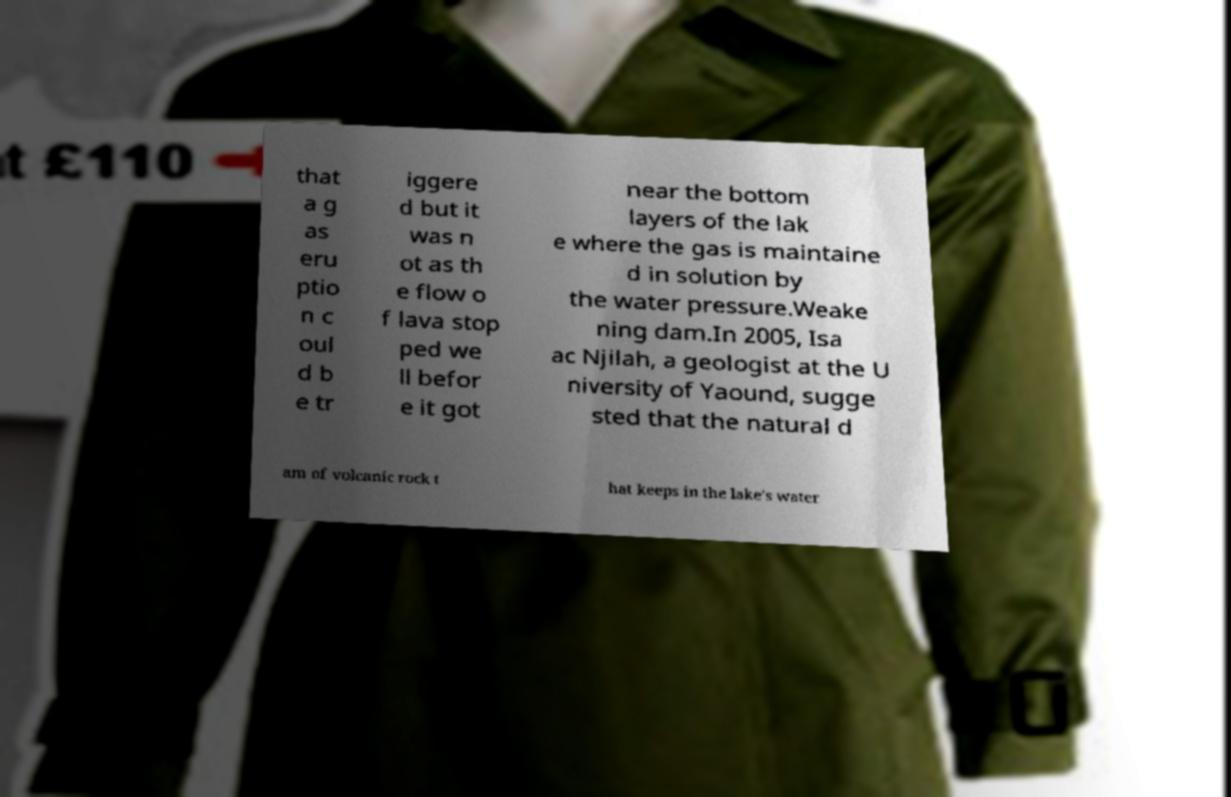Please identify and transcribe the text found in this image. that a g as eru ptio n c oul d b e tr iggere d but it was n ot as th e flow o f lava stop ped we ll befor e it got near the bottom layers of the lak e where the gas is maintaine d in solution by the water pressure.Weake ning dam.In 2005, Isa ac Njilah, a geologist at the U niversity of Yaound, sugge sted that the natural d am of volcanic rock t hat keeps in the lake's water 